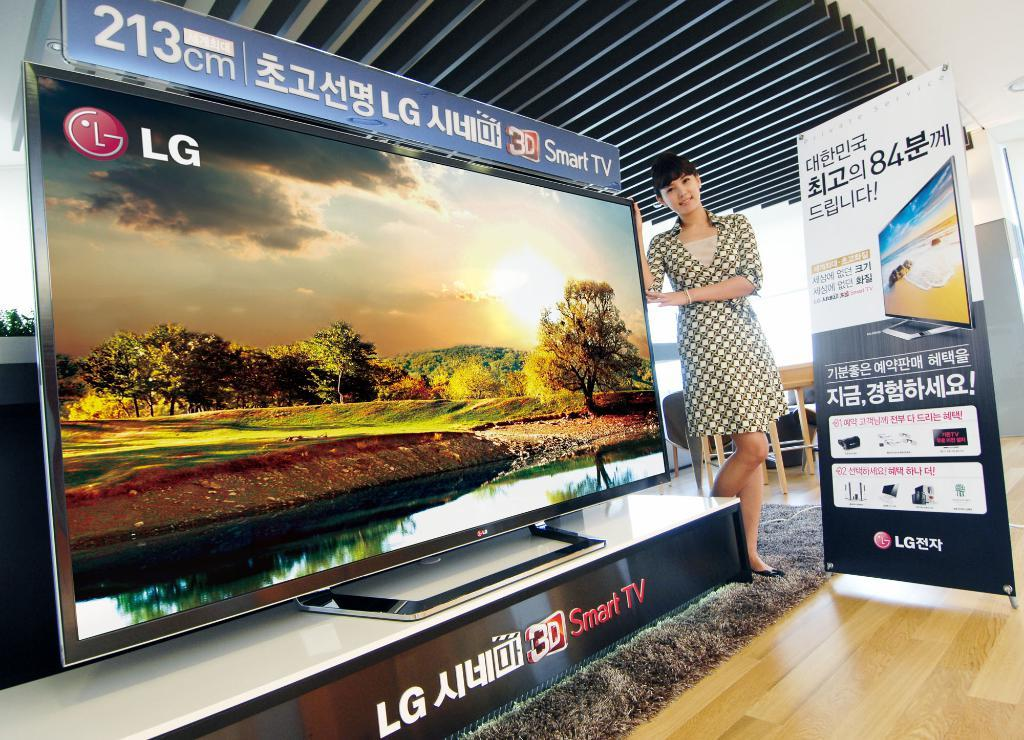Provide a one-sentence caption for the provided image. A young woman stands next to a huge LG tv on a display stand. 